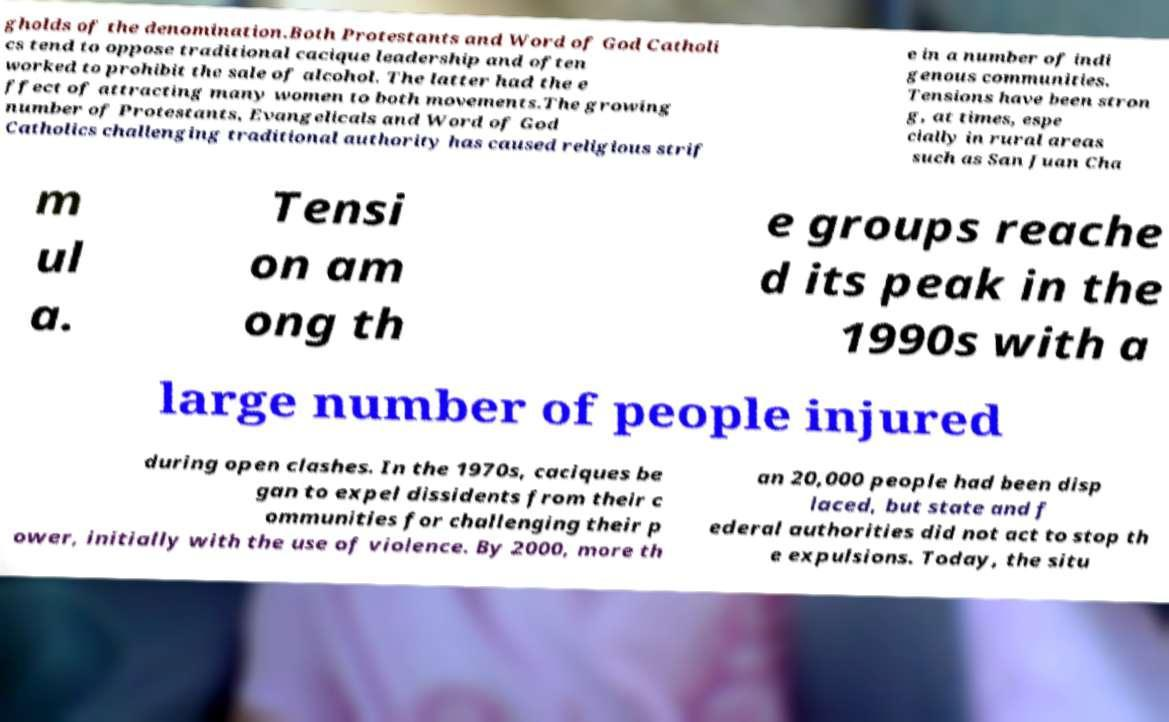Please read and relay the text visible in this image. What does it say? gholds of the denomination.Both Protestants and Word of God Catholi cs tend to oppose traditional cacique leadership and often worked to prohibit the sale of alcohol. The latter had the e ffect of attracting many women to both movements.The growing number of Protestants, Evangelicals and Word of God Catholics challenging traditional authority has caused religious strif e in a number of indi genous communities. Tensions have been stron g, at times, espe cially in rural areas such as San Juan Cha m ul a. Tensi on am ong th e groups reache d its peak in the 1990s with a large number of people injured during open clashes. In the 1970s, caciques be gan to expel dissidents from their c ommunities for challenging their p ower, initially with the use of violence. By 2000, more th an 20,000 people had been disp laced, but state and f ederal authorities did not act to stop th e expulsions. Today, the situ 